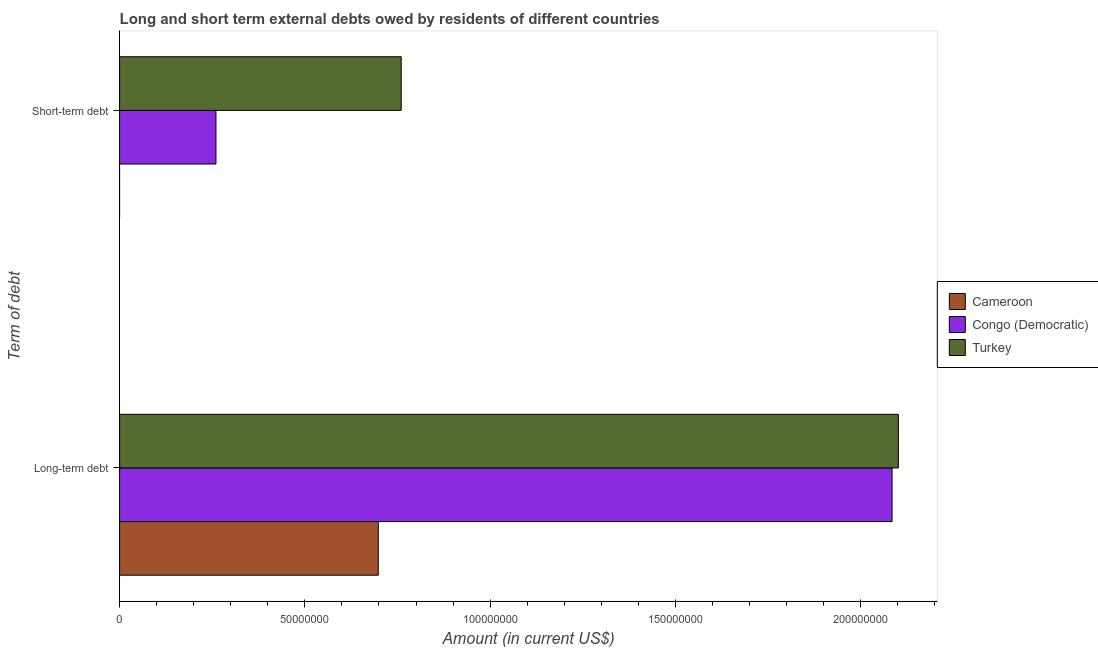How many different coloured bars are there?
Give a very brief answer. 3. Are the number of bars on each tick of the Y-axis equal?
Your response must be concise. No. What is the label of the 2nd group of bars from the top?
Your answer should be compact. Long-term debt. What is the long-term debts owed by residents in Congo (Democratic)?
Keep it short and to the point. 2.08e+08. Across all countries, what is the maximum short-term debts owed by residents?
Give a very brief answer. 7.60e+07. Across all countries, what is the minimum short-term debts owed by residents?
Keep it short and to the point. 0. What is the total long-term debts owed by residents in the graph?
Your answer should be very brief. 4.88e+08. What is the difference between the long-term debts owed by residents in Congo (Democratic) and that in Cameroon?
Offer a very short reply. 1.39e+08. What is the difference between the short-term debts owed by residents in Turkey and the long-term debts owed by residents in Cameroon?
Your answer should be compact. 6.20e+06. What is the average short-term debts owed by residents per country?
Your answer should be very brief. 3.40e+07. What is the difference between the long-term debts owed by residents and short-term debts owed by residents in Turkey?
Your answer should be compact. 1.34e+08. What is the ratio of the long-term debts owed by residents in Cameroon to that in Turkey?
Your answer should be very brief. 0.33. Is the short-term debts owed by residents in Turkey less than that in Congo (Democratic)?
Keep it short and to the point. No. How many countries are there in the graph?
Offer a terse response. 3. What is the difference between two consecutive major ticks on the X-axis?
Your answer should be very brief. 5.00e+07. Are the values on the major ticks of X-axis written in scientific E-notation?
Offer a terse response. No. What is the title of the graph?
Offer a terse response. Long and short term external debts owed by residents of different countries. What is the label or title of the X-axis?
Your answer should be compact. Amount (in current US$). What is the label or title of the Y-axis?
Offer a terse response. Term of debt. What is the Amount (in current US$) in Cameroon in Long-term debt?
Provide a succinct answer. 6.98e+07. What is the Amount (in current US$) of Congo (Democratic) in Long-term debt?
Your answer should be very brief. 2.08e+08. What is the Amount (in current US$) in Turkey in Long-term debt?
Ensure brevity in your answer.  2.10e+08. What is the Amount (in current US$) of Congo (Democratic) in Short-term debt?
Offer a very short reply. 2.60e+07. What is the Amount (in current US$) of Turkey in Short-term debt?
Keep it short and to the point. 7.60e+07. Across all Term of debt, what is the maximum Amount (in current US$) in Cameroon?
Offer a terse response. 6.98e+07. Across all Term of debt, what is the maximum Amount (in current US$) in Congo (Democratic)?
Your answer should be compact. 2.08e+08. Across all Term of debt, what is the maximum Amount (in current US$) in Turkey?
Your answer should be very brief. 2.10e+08. Across all Term of debt, what is the minimum Amount (in current US$) in Congo (Democratic)?
Provide a short and direct response. 2.60e+07. Across all Term of debt, what is the minimum Amount (in current US$) in Turkey?
Give a very brief answer. 7.60e+07. What is the total Amount (in current US$) of Cameroon in the graph?
Offer a terse response. 6.98e+07. What is the total Amount (in current US$) of Congo (Democratic) in the graph?
Keep it short and to the point. 2.34e+08. What is the total Amount (in current US$) of Turkey in the graph?
Ensure brevity in your answer.  2.86e+08. What is the difference between the Amount (in current US$) in Congo (Democratic) in Long-term debt and that in Short-term debt?
Offer a very short reply. 1.82e+08. What is the difference between the Amount (in current US$) of Turkey in Long-term debt and that in Short-term debt?
Ensure brevity in your answer.  1.34e+08. What is the difference between the Amount (in current US$) of Cameroon in Long-term debt and the Amount (in current US$) of Congo (Democratic) in Short-term debt?
Provide a short and direct response. 4.38e+07. What is the difference between the Amount (in current US$) of Cameroon in Long-term debt and the Amount (in current US$) of Turkey in Short-term debt?
Make the answer very short. -6.20e+06. What is the difference between the Amount (in current US$) in Congo (Democratic) in Long-term debt and the Amount (in current US$) in Turkey in Short-term debt?
Give a very brief answer. 1.32e+08. What is the average Amount (in current US$) of Cameroon per Term of debt?
Offer a terse response. 3.49e+07. What is the average Amount (in current US$) in Congo (Democratic) per Term of debt?
Ensure brevity in your answer.  1.17e+08. What is the average Amount (in current US$) of Turkey per Term of debt?
Offer a very short reply. 1.43e+08. What is the difference between the Amount (in current US$) of Cameroon and Amount (in current US$) of Congo (Democratic) in Long-term debt?
Your response must be concise. -1.39e+08. What is the difference between the Amount (in current US$) of Cameroon and Amount (in current US$) of Turkey in Long-term debt?
Offer a very short reply. -1.40e+08. What is the difference between the Amount (in current US$) of Congo (Democratic) and Amount (in current US$) of Turkey in Long-term debt?
Keep it short and to the point. -1.70e+06. What is the difference between the Amount (in current US$) in Congo (Democratic) and Amount (in current US$) in Turkey in Short-term debt?
Provide a succinct answer. -5.00e+07. What is the ratio of the Amount (in current US$) of Congo (Democratic) in Long-term debt to that in Short-term debt?
Ensure brevity in your answer.  8.02. What is the ratio of the Amount (in current US$) of Turkey in Long-term debt to that in Short-term debt?
Your answer should be compact. 2.77. What is the difference between the highest and the second highest Amount (in current US$) in Congo (Democratic)?
Provide a succinct answer. 1.82e+08. What is the difference between the highest and the second highest Amount (in current US$) in Turkey?
Give a very brief answer. 1.34e+08. What is the difference between the highest and the lowest Amount (in current US$) in Cameroon?
Offer a terse response. 6.98e+07. What is the difference between the highest and the lowest Amount (in current US$) of Congo (Democratic)?
Give a very brief answer. 1.82e+08. What is the difference between the highest and the lowest Amount (in current US$) of Turkey?
Make the answer very short. 1.34e+08. 